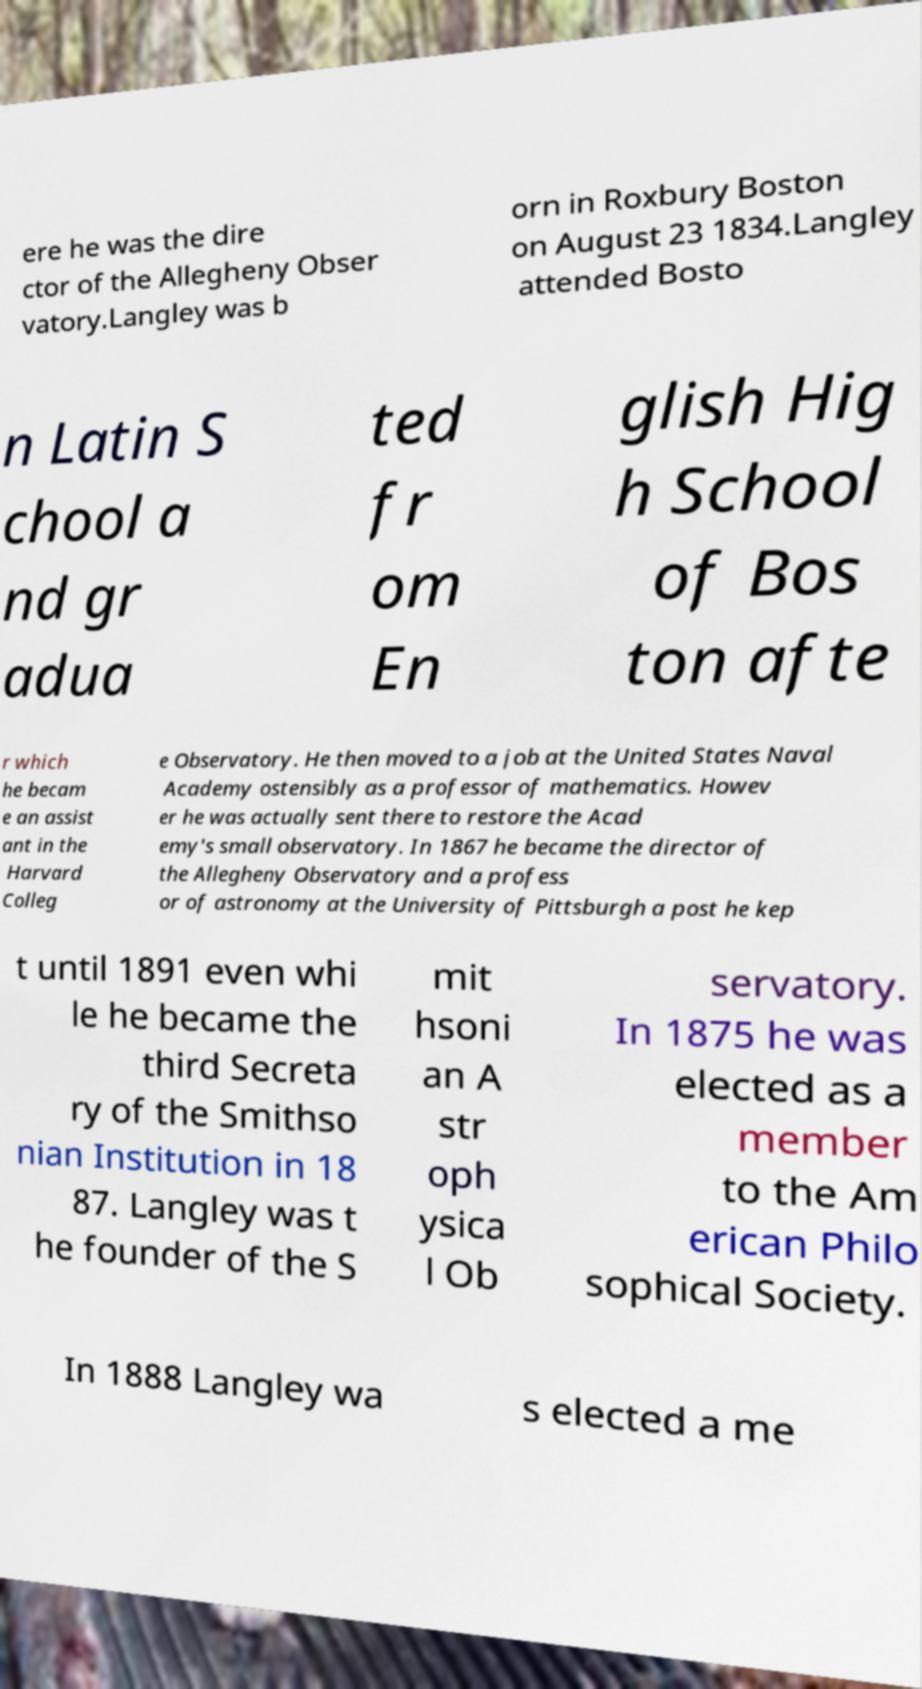Could you assist in decoding the text presented in this image and type it out clearly? ere he was the dire ctor of the Allegheny Obser vatory.Langley was b orn in Roxbury Boston on August 23 1834.Langley attended Bosto n Latin S chool a nd gr adua ted fr om En glish Hig h School of Bos ton afte r which he becam e an assist ant in the Harvard Colleg e Observatory. He then moved to a job at the United States Naval Academy ostensibly as a professor of mathematics. Howev er he was actually sent there to restore the Acad emy's small observatory. In 1867 he became the director of the Allegheny Observatory and a profess or of astronomy at the University of Pittsburgh a post he kep t until 1891 even whi le he became the third Secreta ry of the Smithso nian Institution in 18 87. Langley was t he founder of the S mit hsoni an A str oph ysica l Ob servatory. In 1875 he was elected as a member to the Am erican Philo sophical Society. In 1888 Langley wa s elected a me 